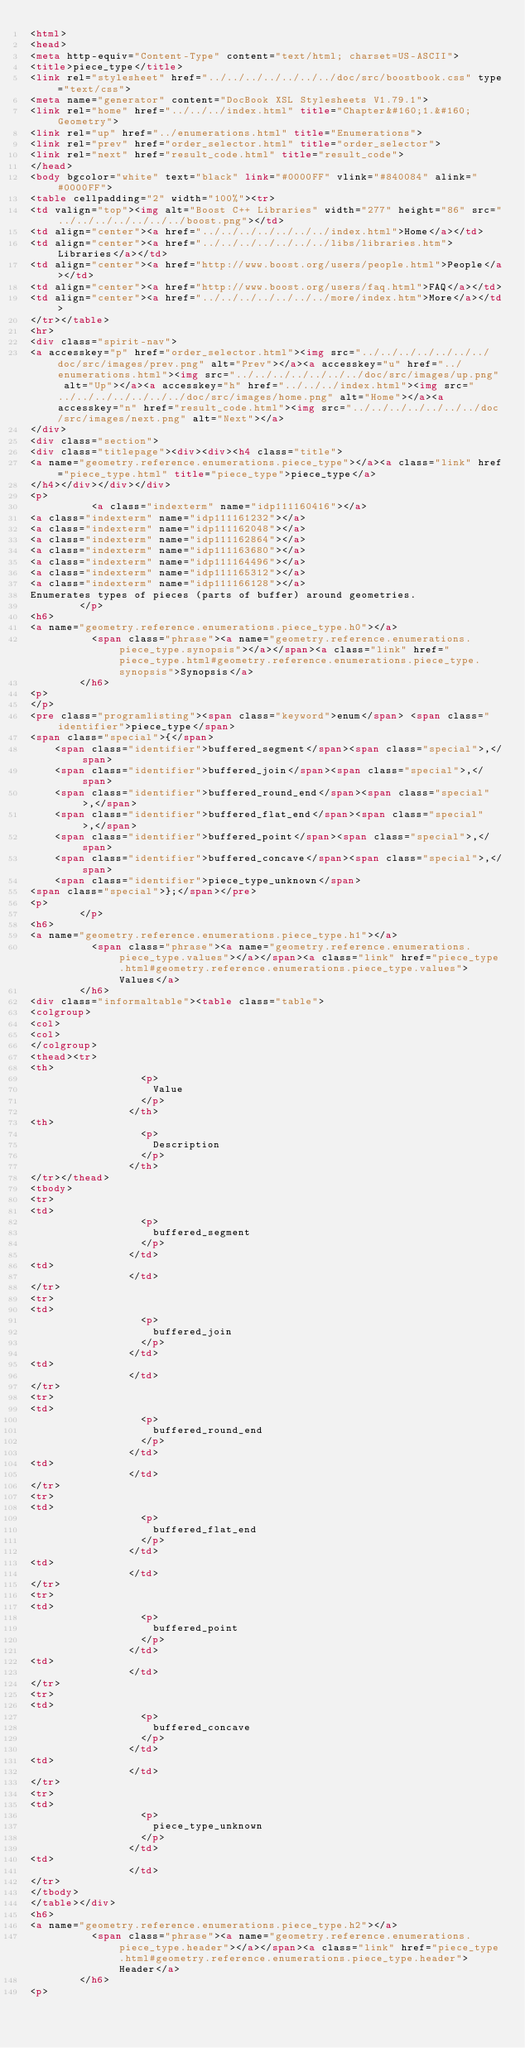<code> <loc_0><loc_0><loc_500><loc_500><_HTML_><html>
<head>
<meta http-equiv="Content-Type" content="text/html; charset=US-ASCII">
<title>piece_type</title>
<link rel="stylesheet" href="../../../../../../../doc/src/boostbook.css" type="text/css">
<meta name="generator" content="DocBook XSL Stylesheets V1.79.1">
<link rel="home" href="../../../index.html" title="Chapter&#160;1.&#160;Geometry">
<link rel="up" href="../enumerations.html" title="Enumerations">
<link rel="prev" href="order_selector.html" title="order_selector">
<link rel="next" href="result_code.html" title="result_code">
</head>
<body bgcolor="white" text="black" link="#0000FF" vlink="#840084" alink="#0000FF">
<table cellpadding="2" width="100%"><tr>
<td valign="top"><img alt="Boost C++ Libraries" width="277" height="86" src="../../../../../../../boost.png"></td>
<td align="center"><a href="../../../../../../../index.html">Home</a></td>
<td align="center"><a href="../../../../../../../libs/libraries.htm">Libraries</a></td>
<td align="center"><a href="http://www.boost.org/users/people.html">People</a></td>
<td align="center"><a href="http://www.boost.org/users/faq.html">FAQ</a></td>
<td align="center"><a href="../../../../../../../more/index.htm">More</a></td>
</tr></table>
<hr>
<div class="spirit-nav">
<a accesskey="p" href="order_selector.html"><img src="../../../../../../../doc/src/images/prev.png" alt="Prev"></a><a accesskey="u" href="../enumerations.html"><img src="../../../../../../../doc/src/images/up.png" alt="Up"></a><a accesskey="h" href="../../../index.html"><img src="../../../../../../../doc/src/images/home.png" alt="Home"></a><a accesskey="n" href="result_code.html"><img src="../../../../../../../doc/src/images/next.png" alt="Next"></a>
</div>
<div class="section">
<div class="titlepage"><div><div><h4 class="title">
<a name="geometry.reference.enumerations.piece_type"></a><a class="link" href="piece_type.html" title="piece_type">piece_type</a>
</h4></div></div></div>
<p>
          <a class="indexterm" name="idp111160416"></a>
<a class="indexterm" name="idp111161232"></a>
<a class="indexterm" name="idp111162048"></a>
<a class="indexterm" name="idp111162864"></a>
<a class="indexterm" name="idp111163680"></a>
<a class="indexterm" name="idp111164496"></a>
<a class="indexterm" name="idp111165312"></a>
<a class="indexterm" name="idp111166128"></a>
Enumerates types of pieces (parts of buffer) around geometries.
        </p>
<h6>
<a name="geometry.reference.enumerations.piece_type.h0"></a>
          <span class="phrase"><a name="geometry.reference.enumerations.piece_type.synopsis"></a></span><a class="link" href="piece_type.html#geometry.reference.enumerations.piece_type.synopsis">Synopsis</a>
        </h6>
<p>
</p>
<pre class="programlisting"><span class="keyword">enum</span> <span class="identifier">piece_type</span>
<span class="special">{</span>
    <span class="identifier">buffered_segment</span><span class="special">,</span>
    <span class="identifier">buffered_join</span><span class="special">,</span>
    <span class="identifier">buffered_round_end</span><span class="special">,</span>
    <span class="identifier">buffered_flat_end</span><span class="special">,</span>
    <span class="identifier">buffered_point</span><span class="special">,</span>
    <span class="identifier">buffered_concave</span><span class="special">,</span>
    <span class="identifier">piece_type_unknown</span>
<span class="special">};</span></pre>
<p>
        </p>
<h6>
<a name="geometry.reference.enumerations.piece_type.h1"></a>
          <span class="phrase"><a name="geometry.reference.enumerations.piece_type.values"></a></span><a class="link" href="piece_type.html#geometry.reference.enumerations.piece_type.values">Values</a>
        </h6>
<div class="informaltable"><table class="table">
<colgroup>
<col>
<col>
</colgroup>
<thead><tr>
<th>
                  <p>
                    Value
                  </p>
                </th>
<th>
                  <p>
                    Description
                  </p>
                </th>
</tr></thead>
<tbody>
<tr>
<td>
                  <p>
                    buffered_segment
                  </p>
                </td>
<td>
                </td>
</tr>
<tr>
<td>
                  <p>
                    buffered_join
                  </p>
                </td>
<td>
                </td>
</tr>
<tr>
<td>
                  <p>
                    buffered_round_end
                  </p>
                </td>
<td>
                </td>
</tr>
<tr>
<td>
                  <p>
                    buffered_flat_end
                  </p>
                </td>
<td>
                </td>
</tr>
<tr>
<td>
                  <p>
                    buffered_point
                  </p>
                </td>
<td>
                </td>
</tr>
<tr>
<td>
                  <p>
                    buffered_concave
                  </p>
                </td>
<td>
                </td>
</tr>
<tr>
<td>
                  <p>
                    piece_type_unknown
                  </p>
                </td>
<td>
                </td>
</tr>
</tbody>
</table></div>
<h6>
<a name="geometry.reference.enumerations.piece_type.h2"></a>
          <span class="phrase"><a name="geometry.reference.enumerations.piece_type.header"></a></span><a class="link" href="piece_type.html#geometry.reference.enumerations.piece_type.header">Header</a>
        </h6>
<p></code> 